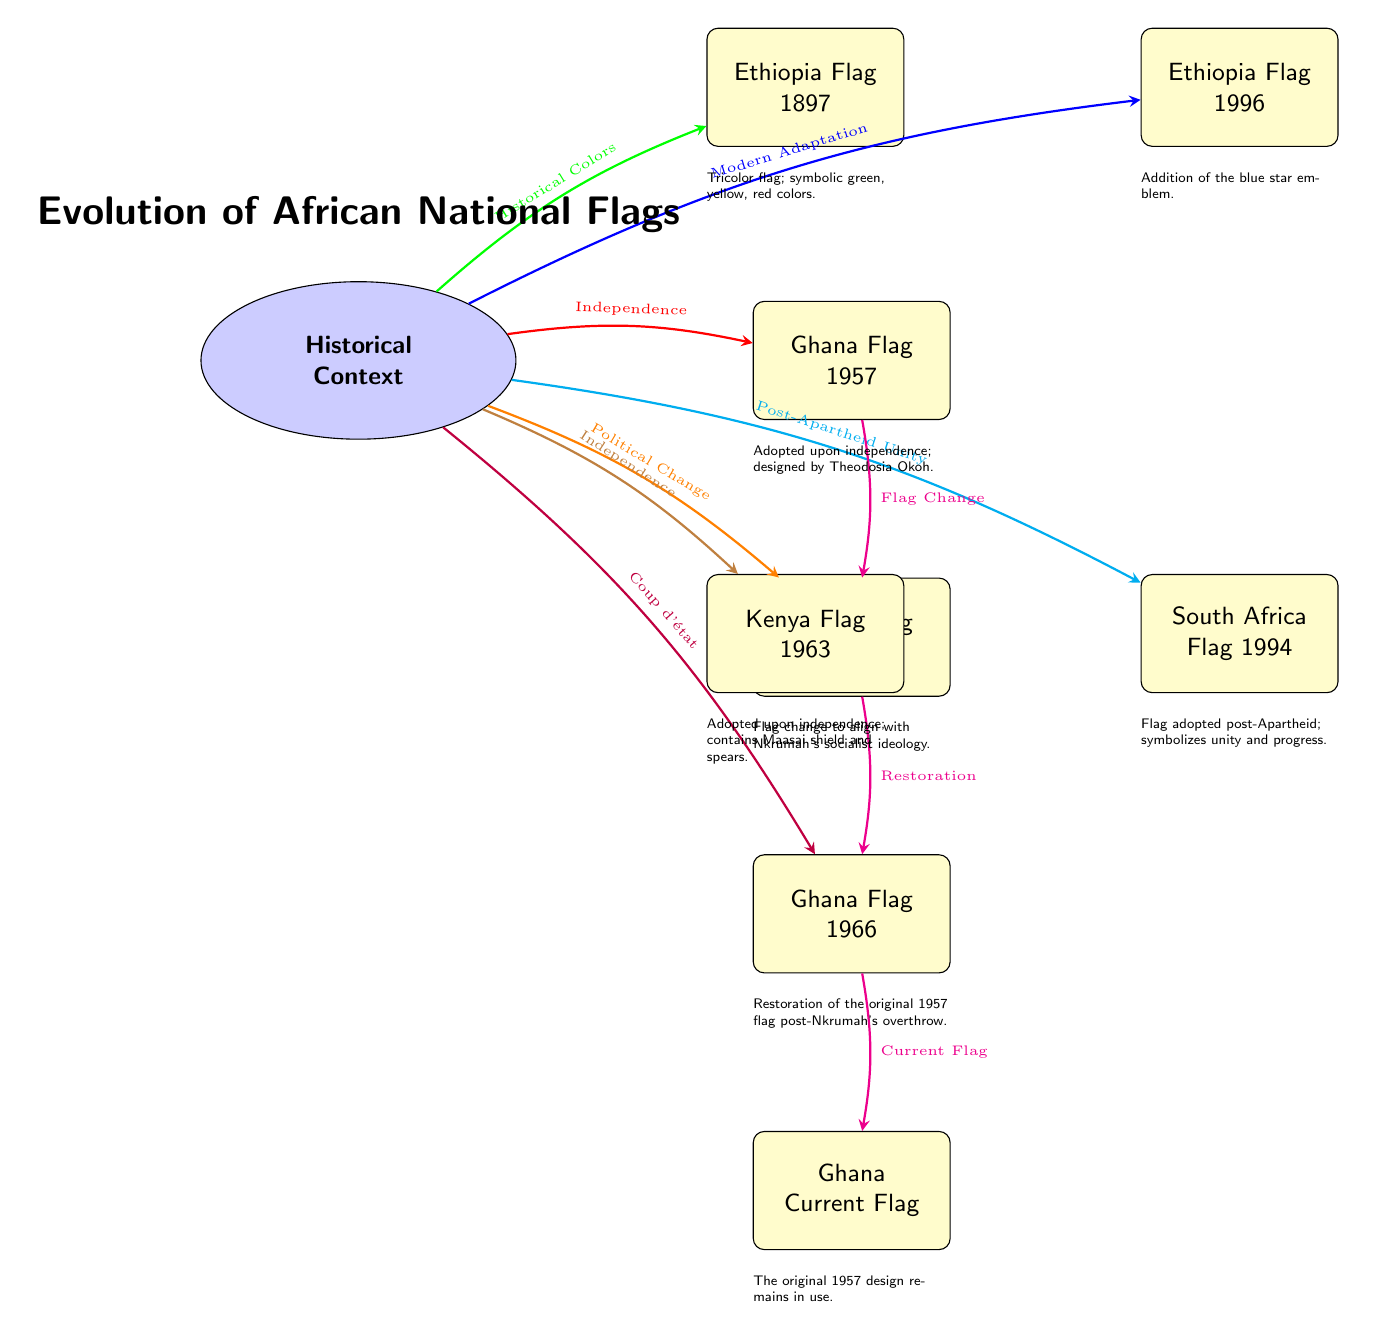What is the flag of Ghana adopted in 1957? The diagram clearly shows that the flag for Ghana adopted in 1957 is titled "Ghana Flag 1957."
Answer: Ghana Flag 1957 What event is associated with the Ghana Flag 1964? The arrow from the "Historical Context" node to "Ghana Flag 1964" is labeled "Political Change," indicating this event's association with the flag.
Answer: Political Change How many Ghana flags are depicted in the diagram? The diagram displays four nodes representing different flags of Ghana: one each for 1957, 1964, 1966, and the current flag.
Answer: Four What color emblem was added to the Ethiopian flag in 1996? The description below the "Ethiopia Flag 1996" node states that an "addition of the blue star emblem" was made to the flag.
Answer: Blue star emblem Which flag is associated with the year 1994 in South Africa? The node specifically labeled "South Africa Flag 1994" indicates the flag adopted in that year.
Answer: South Africa Flag 1994 What does the arrow from the Historical Context to the Kenya Flag signify? The arrow labeled "Independence" connects the Historical Context to "Kenya Flag 1963," illustrating that the Kenya flag change is tied to its independence.
Answer: Independence What does the restoration of the original 1957 flag in Ghana indicate? The transition arrow from "Ghana Flag 1964" to "Ghana Flag 1966" is labeled "Restoration," which suggests a return to the original flag after the previous political change.
Answer: Restoration Which country's flag was adopted upon independence in 1963? The diagram shows that the "Kenya Flag 1963" node is linked to the Historical Context by an arrow labeled "Independence," confirming its adoption during this time.
Answer: Kenya Flag 1963 What historical context change relates to the shift from Ghana Flag 1957 to Ghana Flag 1964? The arrow directly connecting both flags is marked "Flag Change," indicating a deliberate modification motivated by political actions.
Answer: Flag Change 